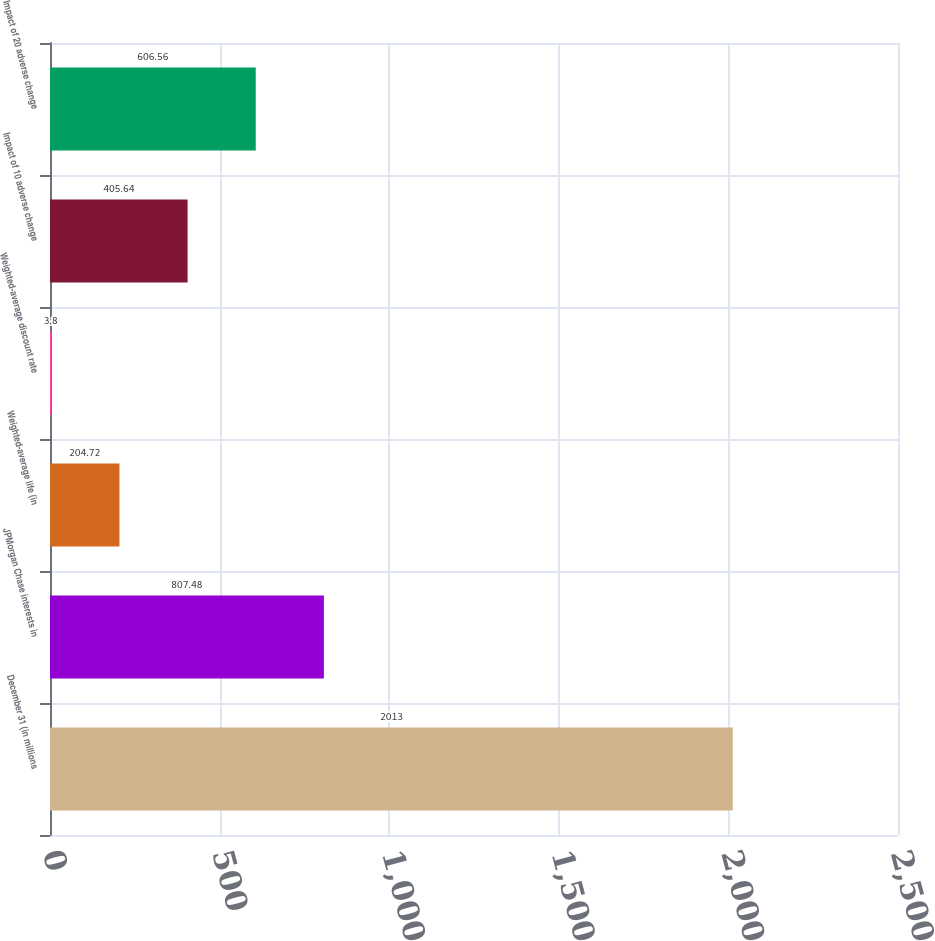<chart> <loc_0><loc_0><loc_500><loc_500><bar_chart><fcel>December 31 (in millions<fcel>JPMorgan Chase interests in<fcel>Weighted-average life (in<fcel>Weighted-average discount rate<fcel>Impact of 10 adverse change<fcel>Impact of 20 adverse change<nl><fcel>2013<fcel>807.48<fcel>204.72<fcel>3.8<fcel>405.64<fcel>606.56<nl></chart> 